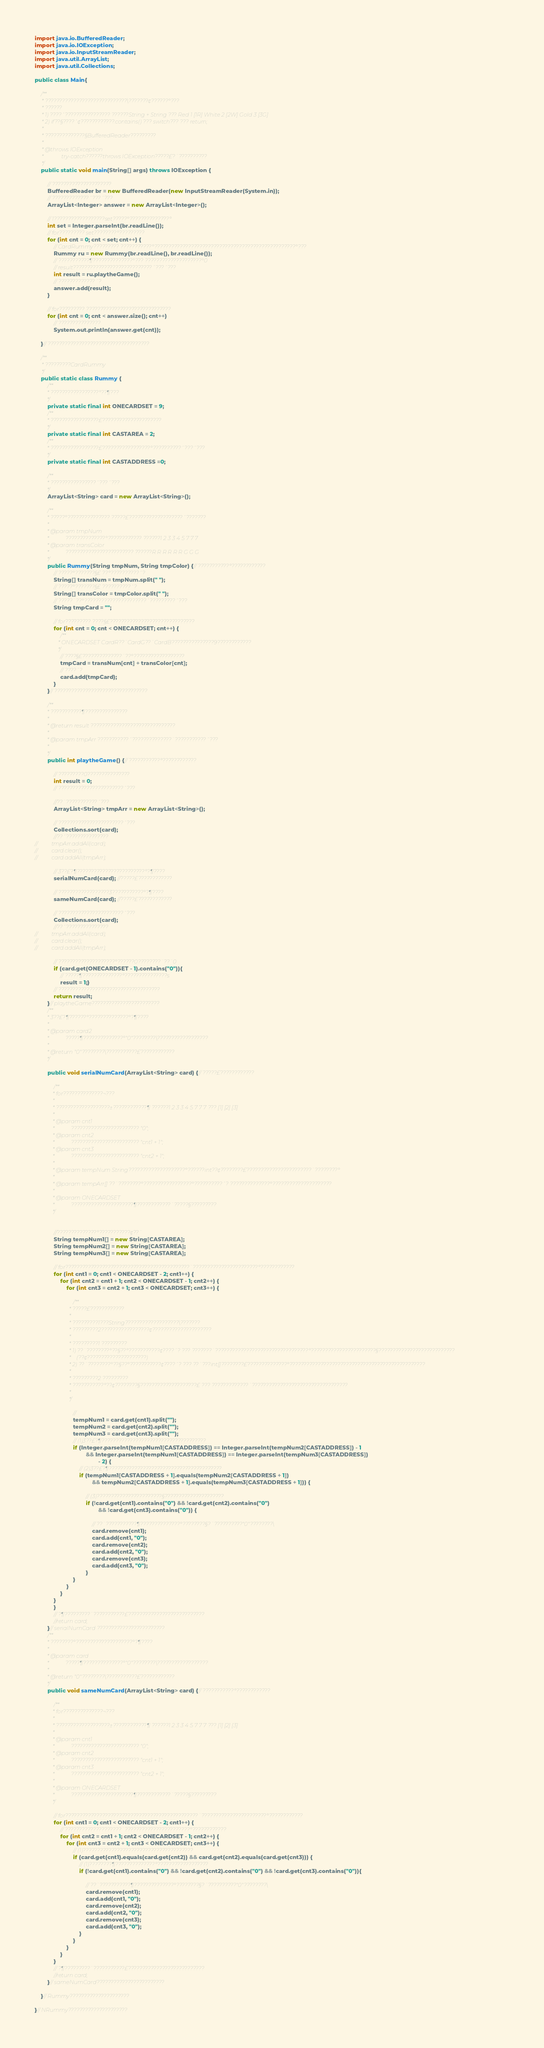Convert code to text. <code><loc_0><loc_0><loc_500><loc_500><_Java_>

import java.io.BufferedReader;
import java.io.IOException;
import java.io.InputStreamReader;
import java.util.ArrayList;
import java.util.Collections;

public class Main{

	/**
	 * ?????????????????????????????\???????¢??????°???
	 * ??????
	 * 1) ????´???????????????? ??????String + String ??? Red 1 [1R] White 2 [2W] Gold 3 [3G]
	 * 2) if??§????´¢????????????.contains() ??? switch??? ??? return;
	 *
	 * ??????????????§BufferedReader?????????
	 *
	 * @throws IOException
	 *             try-catch??????throws IOException?????£?¨??????????
	 */
	public static void main(String[] args) throws IOException {

		// ?????????????????????
		BufferedReader br = new BufferedReader(new InputStreamReader(System.in));
		// ?????????????´???´???
		ArrayList<Integer> answer = new ArrayList<Integer>();

		// 1??????????????????set?????°??????????????°
		int set = Integer.parseInt(br.readLine());
		// for????????? set????????°?????????
		for (int cnt = 0; cnt < set; cnt++) {
			// CardRummy????????? ???????????°??????????????????????????????????????????????????°???
			Rummy ru = new Rummy(br.readLine(), br.readLine());
			// ???????????¶??????????????°??? ????????????????????°0
			// result????????????????????????????´???´???
			int result = ru.playtheGame();
			// ?????????????´?
			answer.add(result);
		}

		// for????????? ??????????????????????????????
		for (int cnt = 0; cnt < answer.size(); cnt++)
			// ???????????????
			System.out.println(answer.get(cnt));

	}// ????????????????????????????????????

	/**
	 * ?????????CardRummy
	 */
	public static class Rummy {
		/**
		 * ?????????????????°??¶???
		 */
		private static final int ONECARDSET = 9;
		/**
		 * ?????????????????£?????????????????????
		 */
		private static final int CASTAREA = 2;
		/**
		 * ?????????????????£?????????????????°??????????´???´???
		 */
		private static final int CASTADDRESS =0;

		/**
		 * ????????????????´???´???
		 */
		ArrayList<String> card = new ArrayList<String>();

		/**
		 * ?????°??????????????? ?????£???????????????????´???????
		 *
		 * @param tmpNum
		 *            ??????????????°???????????? ??????1 2 3 3 4 5 7 7 7
		 * @param transColor
		 *            ???????????????????????? ??????R R R R R R G G G
		 */
		public Rummy(String tmpNum, String tmpColor) {// ???????????°????????????
			// ?????°???????§£ ??°??????????´?
			String[] transNum = tmpNum.split(" ");
			// ?????°???????§£ ??????????´?
			String[] transColor = tmpColor.split(" ");
			// ?????¨??°??????????????????????´?????????´???
			String tmpCard = "";

			// for????????? ????§£??????????????????????????????
			for (int cnt = 0; cnt < ONECARDSET; cnt++) {
				/**
				 * ONECARDSET CardR??¨CardG??¨CardB???????????????9????????????
				 */
				// ????§£??????????????¨??°??????????????????
				tmpCard = transNum[cnt] + transColor[cnt];
				// ????´?
				card.add(tmpCard);
			}
		}// ?????????????????????????????????

		/**
		 * ???????????¶???????????????
		 *
		 * @return result ??????????????????????????????
		 *
		 * @param tmpArr ???????????´??????????????¨???????????´???
		 *
		 */
		public int playtheGame() {// ???????????°????????????

			// ?????????0???????????????
			int result = 0;
			// ???????????????????????´???

			//??¨???????????´???
			ArrayList<String> tmpArr = new ArrayList<String>();

			// ???????????????????????´???
			Collections.sort(card);
			//??´???????????????
//			tmpArr.addAll(card);
//			card.clear();
//			card.addAll(tmpArr);

			// 3??£?¶????????????????????????°?¶????
			serialNumCard(card); //?????£????????????

			// ??????????????????3???????????°?¶????
			sameNumCard(card); //?????£????????????

			// ???????????????????????´???
			Collections.sort(card);
			//??´???????????????
//			tmpArr.addAll(card);
//			card.clear();
//			card.addAll(tmpArr);

			// ????????????????????°??????0????????¨??¨0
			if (card.get(ONECARDSET - 1).contains("0")){
				// ?????¶??????????????°???????????????s
				result = 1;}
			// ????????????????????????????????????
			return result;
		}// playtheGame????????????????????????
		/**
		 * 3??£?¶??????°??????????????°?¶????
		 *
		 * @param card2
		 *            ?????¶??????????????°"0"????????\??????????????????
		 *
		 * @return "0"????????\???????????£????????????
		 */

		public void serialNumCard(ArrayList<String> card) {// ?????£????????????

			/**
			 * for??????????????¬???
			 *
			 * ???????????????????±????????????¶ ??????1 2 3 3 4 5 7 7 7 ??? [1] [2] [3]
			 *
			 * @param cnt1
			 *            ???????????????????????? "0";
			 * @param cnt2
			 *            ???????????????????????? "cnt1 + 1";
			 * @param cnt3
			 *            ???????????????????????? "cnt2 + 1";
			 *
			 * @param tempNum String????????????????????°??????int??¢????????£???????????????????????¨????????°
			 *
			 * @param tempArr[] ??¨????????°?????????????????°??????????´? ??????????????°?????????????????????
			 *
			 * @param ONECARDSET
			 *            ??????????????????????¶????????????¨?????§?????????
			 */


			//??????????????°???????????¢??¨
			String tempNum1[] = new String[CASTAREA];
			String tempNum2[] = new String[CASTAREA];
			String tempNum3[] = new String[CASTAREA];

			// for????????????????????????????????????????????¨???????????????????????°????????????
			for (int cnt1 = 0; cnt1 < ONECARDSET - 2; cnt1++) {
				for (int cnt2 = cnt1 + 1; cnt2 < ONECARDSET - 1; cnt2++) {
					for (int cnt3 = cnt2 + 1; cnt3 < ONECARDSET; cnt3++) {

						/**
						 * ?????£????????????
						 *
						 * ?????????1???String???????????????????\???????
						 * ?????????2?????????????????¢?????????????????????
						 *
						 * ?????????1 ?????????
						 * 1) ??¨????????°??§??°???????????¢????´? ??? ???????¨?????????????????????????????????°???????????????????????§???????????????????????????
						 *    (??¢?????????????????????)
						 * 2) ??¨????????°??§??°???????????¢????´? ??? ??¨???int[]????????£??????????????°????????????????????????????????????????????????
						 *
						 * ?????????2 ?????????
						 * ???????????°??¢????????§????????????????????£ ??? ?????????????¨??????????????????????????????????
						 *
						 */

						//
						tempNum1 = card.get(cnt1).split("");
						tempNum2 = card.get(cnt2).split("");
						tempNum3 = card.get(cnt3).split("");
						// (1)3??£?¶?????????????????????????????????????
						if (Integer.parseInt(tempNum1[CASTADDRESS]) == Integer.parseInt(tempNum2[CASTADDRESS]) - 1
								&& Integer.parseInt(tempNum1[CASTADDRESS]) == Integer.parseInt(tempNum3[CASTADDRESS])
										- 2) {
							// (2)3??£?¶????????????????????????????????????????
							if (tempNum1[CASTADDRESS + 1].equals(tempNum2[CASTADDRESS + 1])
									&& tempNum2[CASTADDRESS + 1].equals(tempNum3[CASTADDRESS + 1])) {

								// (3)???????????????????????§?????????????????????
								if (!card.get(cnt1).contains("0") && !card.get(cnt2).contains("0")
										&& !card.get(cnt3).contains("0")) {

									// ??¨???????????¶??????????????°????????§?¨??????????"0"????????\
									card.remove(cnt1);
									card.add(cnt1, "0");
									card.remove(cnt2);
									card.add(cnt2, "0");
									card.remove(cnt3);
									card.add(cnt3, "0");
								}
						}
					}
				}
			}
			}
			// ?¶?????????¨???????????£???????????????????????????
			//return card;
		}// serialNumCard ????????????????????????
		/**
		 * ????????°????????????????????°?¶????
		 *
		 * @param card
		 *            ?????¶??????????????°"0"????????\??????????????????
		 *
		 * @return "0"????????\???????????£????????????
		 */
		public void sameNumCard(ArrayList<String> card) {// ???????????°????????????

			/**
			 * for??????????????¬???
			 *
			 * ???????????????????±????????????¶ ??????1 2 3 3 4 5 7 7 7 ??? [1] [2] [3]
			 *
			 * @param cnt1
			 *            ???????????????????????? "0";
			 * @param cnt2
			 *            ???????????????????????? "cnt1 + 1";
			 * @param cnt3
			 *            ???????????????????????? "cnt2 + 1";
			 *
			 * @param ONECARDSET
			 *            ??????????????????????¶????????????¨?????§?????????
			 */

			// for???????????????????????????????????????????????¨???????????????????????°????????????
			for (int cnt1 = 0; cnt1 < ONECARDSET - 2; cnt1++) {
				// ????????????????????¨???????????????????????°????????????
				for (int cnt2 = cnt1 + 1; cnt2 < ONECARDSET - 1; cnt2++) {
					for (int cnt3 = cnt2 + 1; cnt3 < ONECARDSET; cnt3++) {
						// (1)???????????????????????????????????????
						if (card.get(cnt1).equals(card.get(cnt2)) && card.get(cnt2).equals(card.get(cnt3))) {
							// (1)????????¶??????????????°??????????????????
							if (!card.get(cnt1).contains("0") && !card.get(cnt2).contains("0") && !card.get(cnt3).contains("0")){

								// ??¨???????????¶??????????????°????????§?¨??????????"0"????????\
								card.remove(cnt1);
								card.add(cnt1, "0");
								card.remove(cnt2);
								card.add(cnt2, "0");
								card.remove(cnt3);
								card.add(cnt3, "0");
							}
						}
					}
				}
			}
			// ?¶?????????¨???????????£???????????????????????????
			//return card;
		}// sameNumCard????????????????????????

	}// Rummy?????????????????????

}// NRummy?????????????????????</code> 